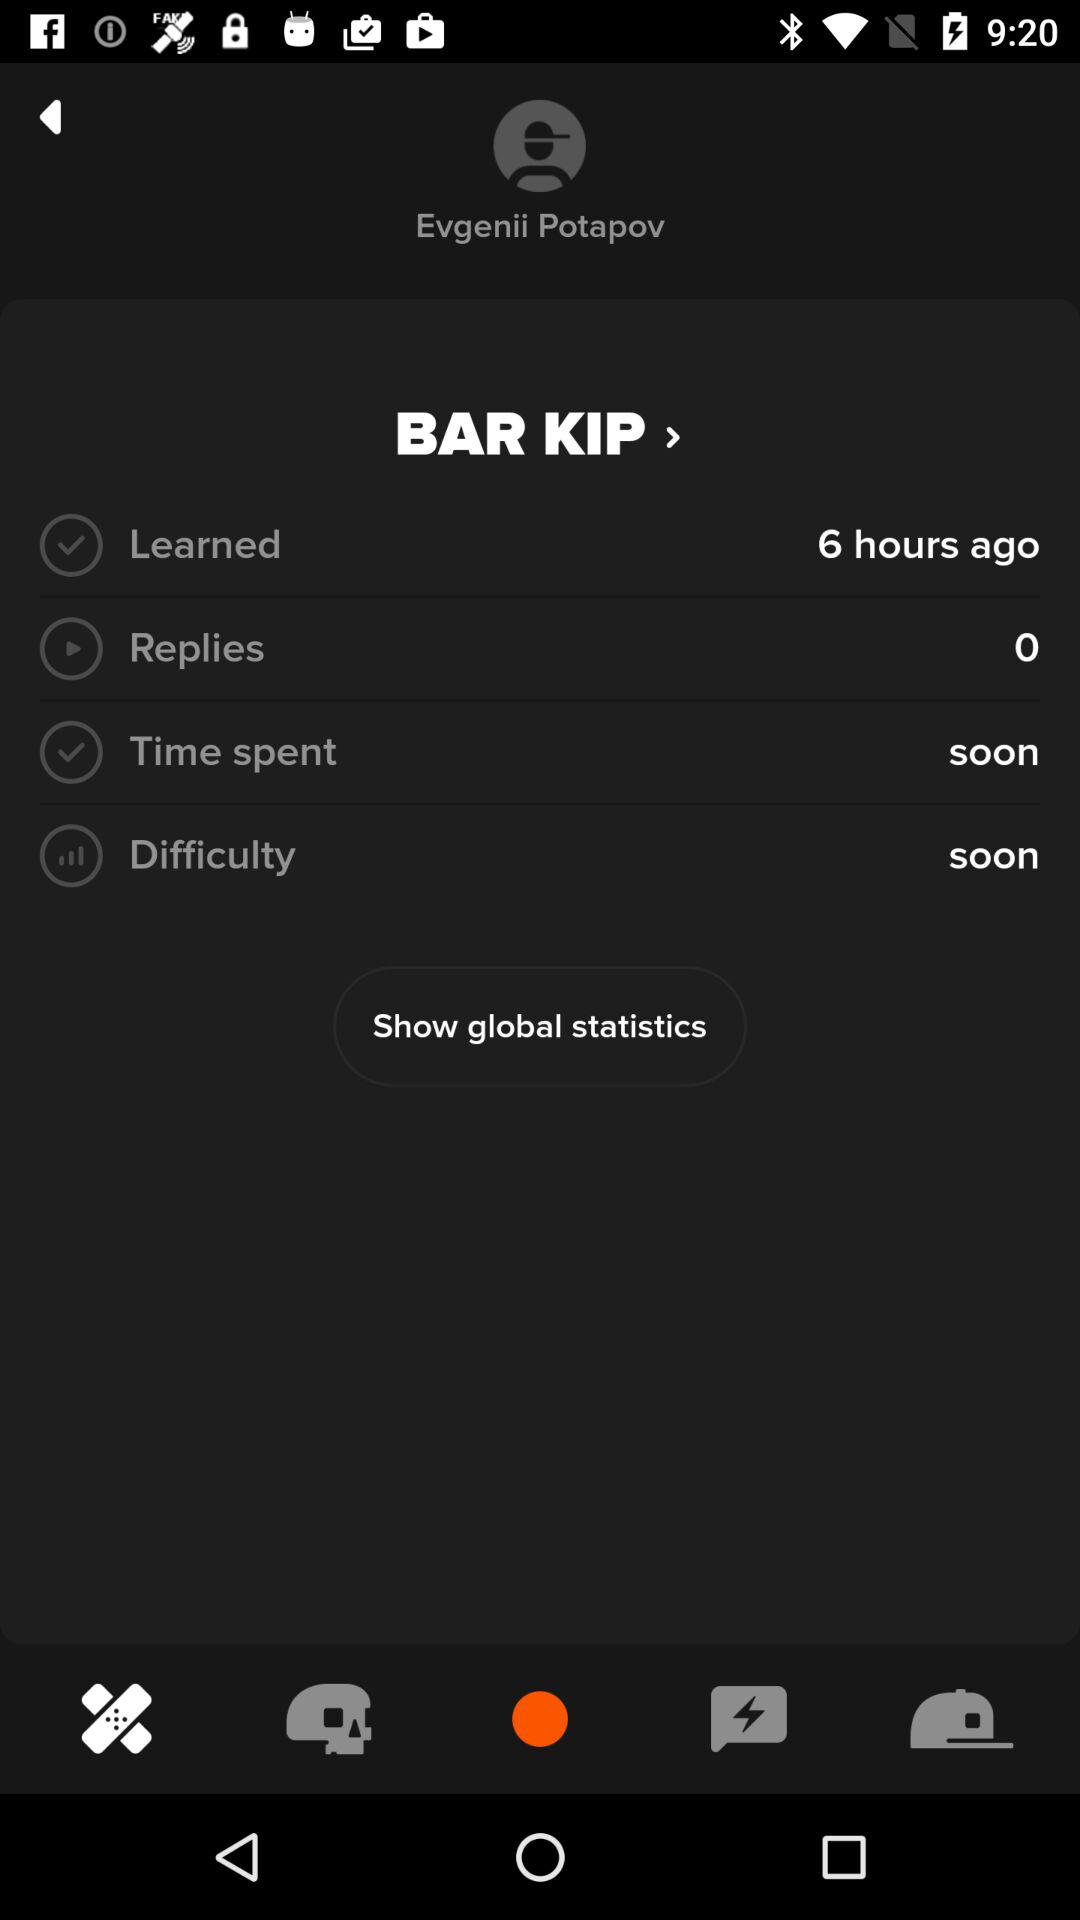How long ago was "BAR KIP" learned? It was learned 6 hours ago. 